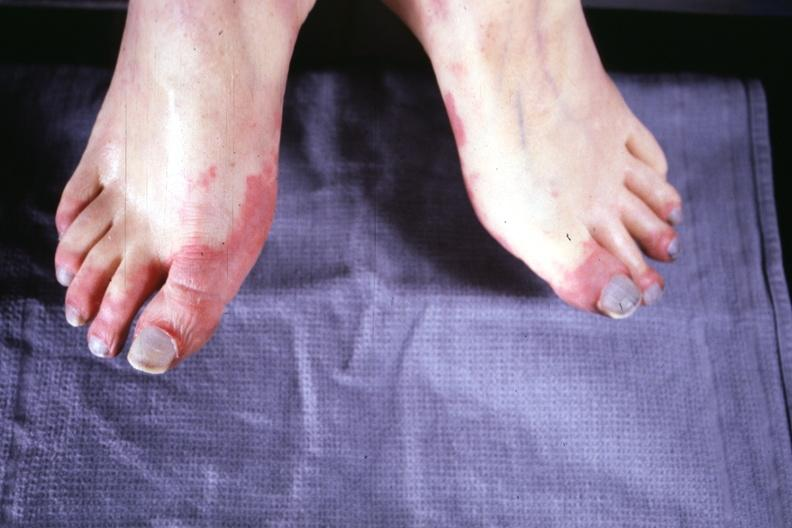how does this image show early lesion?
Answer the question using a single word or phrase. With erythematous appearance 